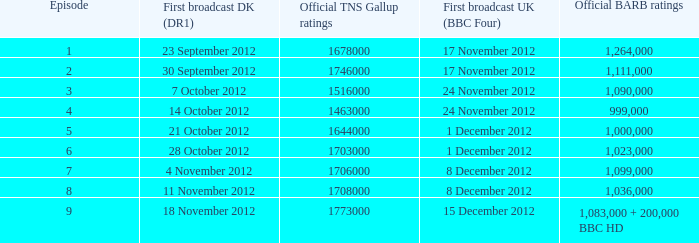When was the episode with a 999,000 BARB rating first aired in Denmark? 14 October 2012. 